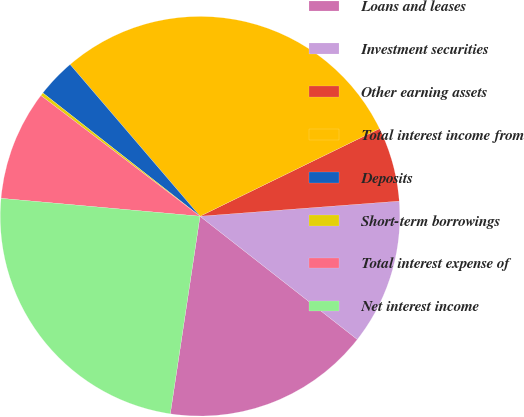Convert chart to OTSL. <chart><loc_0><loc_0><loc_500><loc_500><pie_chart><fcel>Loans and leases<fcel>Investment securities<fcel>Other earning assets<fcel>Total interest income from<fcel>Deposits<fcel>Short-term borrowings<fcel>Total interest expense of<fcel>Net interest income<nl><fcel>16.8%<fcel>11.78%<fcel>6.02%<fcel>29.04%<fcel>3.14%<fcel>0.26%<fcel>8.9%<fcel>24.05%<nl></chart> 